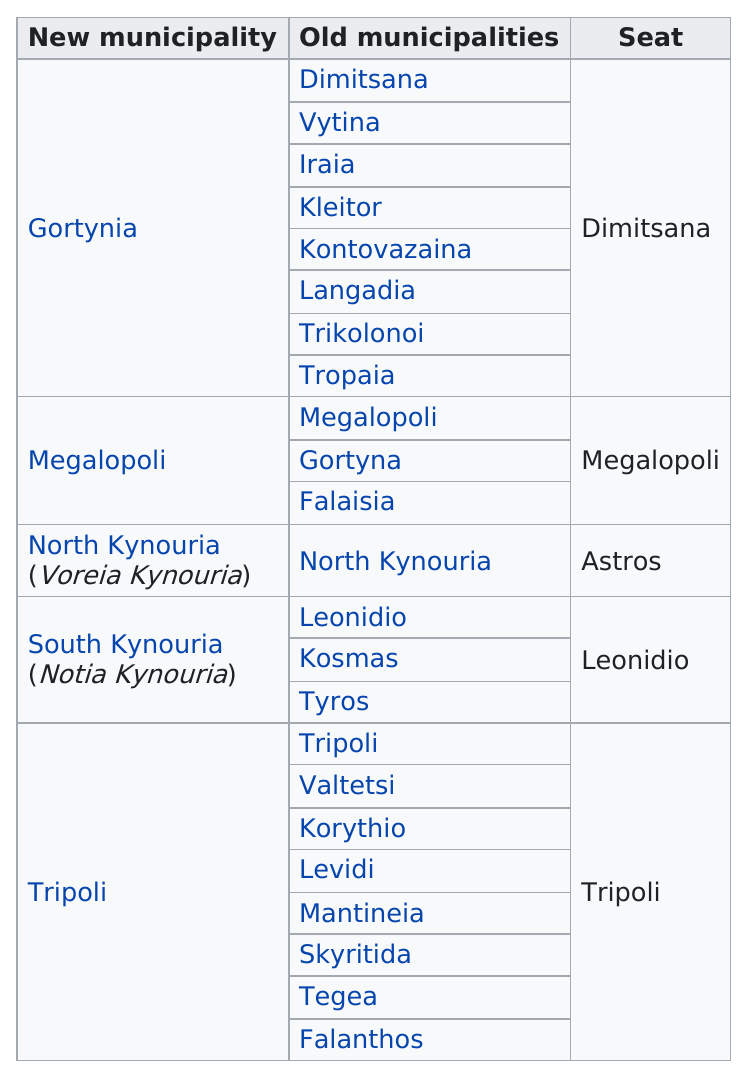List a handful of essential elements in this visual. Upon the reformation of Arcadia in 2011, a total of 5 municipalities were created. The new municipality of Tyros is located in the region of South Kynouria. Tripoli, which underwent reformation in 2011, is still considered a municipality in Arcadia. What is the seat for North Kyrnouria? Astros. In Tripoli, there were 8 old municipalities. 